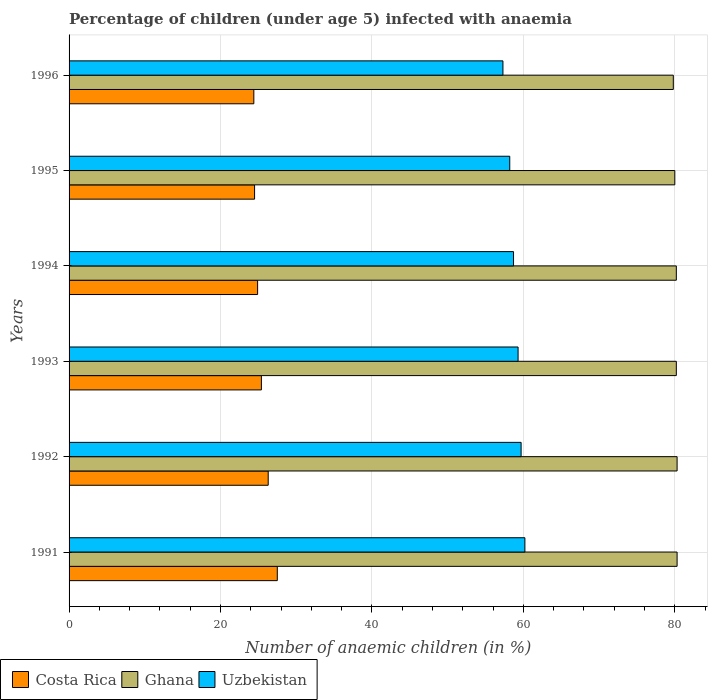How many different coloured bars are there?
Your answer should be very brief. 3. How many groups of bars are there?
Your answer should be compact. 6. How many bars are there on the 2nd tick from the top?
Your response must be concise. 3. In how many cases, is the number of bars for a given year not equal to the number of legend labels?
Offer a terse response. 0. What is the percentage of children infected with anaemia in in Uzbekistan in 1994?
Keep it short and to the point. 58.7. Across all years, what is the maximum percentage of children infected with anaemia in in Uzbekistan?
Your answer should be compact. 60.2. Across all years, what is the minimum percentage of children infected with anaemia in in Uzbekistan?
Your answer should be compact. 57.3. In which year was the percentage of children infected with anaemia in in Ghana maximum?
Your response must be concise. 1991. What is the total percentage of children infected with anaemia in in Costa Rica in the graph?
Your answer should be very brief. 153. What is the difference between the percentage of children infected with anaemia in in Uzbekistan in 1991 and that in 1993?
Provide a succinct answer. 0.9. What is the difference between the percentage of children infected with anaemia in in Ghana in 1994 and the percentage of children infected with anaemia in in Costa Rica in 1995?
Make the answer very short. 55.7. What is the average percentage of children infected with anaemia in in Ghana per year?
Keep it short and to the point. 80.13. In the year 1996, what is the difference between the percentage of children infected with anaemia in in Uzbekistan and percentage of children infected with anaemia in in Ghana?
Provide a short and direct response. -22.5. What is the ratio of the percentage of children infected with anaemia in in Uzbekistan in 1993 to that in 1996?
Make the answer very short. 1.03. Is the percentage of children infected with anaemia in in Uzbekistan in 1993 less than that in 1995?
Give a very brief answer. No. What is the difference between the highest and the lowest percentage of children infected with anaemia in in Costa Rica?
Provide a short and direct response. 3.1. In how many years, is the percentage of children infected with anaemia in in Uzbekistan greater than the average percentage of children infected with anaemia in in Uzbekistan taken over all years?
Your answer should be compact. 3. Is the sum of the percentage of children infected with anaemia in in Ghana in 1993 and 1995 greater than the maximum percentage of children infected with anaemia in in Uzbekistan across all years?
Your answer should be compact. Yes. What does the 3rd bar from the bottom in 1995 represents?
Your answer should be very brief. Uzbekistan. Is it the case that in every year, the sum of the percentage of children infected with anaemia in in Ghana and percentage of children infected with anaemia in in Costa Rica is greater than the percentage of children infected with anaemia in in Uzbekistan?
Offer a terse response. Yes. How many bars are there?
Your response must be concise. 18. How many years are there in the graph?
Provide a short and direct response. 6. What is the difference between two consecutive major ticks on the X-axis?
Your answer should be compact. 20. Are the values on the major ticks of X-axis written in scientific E-notation?
Provide a succinct answer. No. Where does the legend appear in the graph?
Keep it short and to the point. Bottom left. How many legend labels are there?
Give a very brief answer. 3. What is the title of the graph?
Offer a very short reply. Percentage of children (under age 5) infected with anaemia. What is the label or title of the X-axis?
Make the answer very short. Number of anaemic children (in %). What is the Number of anaemic children (in %) of Ghana in 1991?
Make the answer very short. 80.3. What is the Number of anaemic children (in %) in Uzbekistan in 1991?
Your response must be concise. 60.2. What is the Number of anaemic children (in %) in Costa Rica in 1992?
Ensure brevity in your answer.  26.3. What is the Number of anaemic children (in %) in Ghana in 1992?
Make the answer very short. 80.3. What is the Number of anaemic children (in %) of Uzbekistan in 1992?
Provide a succinct answer. 59.7. What is the Number of anaemic children (in %) of Costa Rica in 1993?
Give a very brief answer. 25.4. What is the Number of anaemic children (in %) of Ghana in 1993?
Give a very brief answer. 80.2. What is the Number of anaemic children (in %) in Uzbekistan in 1993?
Provide a succinct answer. 59.3. What is the Number of anaemic children (in %) of Costa Rica in 1994?
Offer a terse response. 24.9. What is the Number of anaemic children (in %) of Ghana in 1994?
Your answer should be compact. 80.2. What is the Number of anaemic children (in %) of Uzbekistan in 1994?
Offer a very short reply. 58.7. What is the Number of anaemic children (in %) of Ghana in 1995?
Your answer should be very brief. 80. What is the Number of anaemic children (in %) of Uzbekistan in 1995?
Provide a short and direct response. 58.2. What is the Number of anaemic children (in %) in Costa Rica in 1996?
Provide a short and direct response. 24.4. What is the Number of anaemic children (in %) of Ghana in 1996?
Make the answer very short. 79.8. What is the Number of anaemic children (in %) of Uzbekistan in 1996?
Your answer should be very brief. 57.3. Across all years, what is the maximum Number of anaemic children (in %) in Ghana?
Your response must be concise. 80.3. Across all years, what is the maximum Number of anaemic children (in %) of Uzbekistan?
Offer a very short reply. 60.2. Across all years, what is the minimum Number of anaemic children (in %) in Costa Rica?
Provide a succinct answer. 24.4. Across all years, what is the minimum Number of anaemic children (in %) of Ghana?
Offer a very short reply. 79.8. Across all years, what is the minimum Number of anaemic children (in %) in Uzbekistan?
Ensure brevity in your answer.  57.3. What is the total Number of anaemic children (in %) in Costa Rica in the graph?
Your answer should be very brief. 153. What is the total Number of anaemic children (in %) in Ghana in the graph?
Your answer should be compact. 480.8. What is the total Number of anaemic children (in %) of Uzbekistan in the graph?
Your answer should be compact. 353.4. What is the difference between the Number of anaemic children (in %) of Costa Rica in 1991 and that in 1992?
Offer a very short reply. 1.2. What is the difference between the Number of anaemic children (in %) of Costa Rica in 1991 and that in 1993?
Your answer should be compact. 2.1. What is the difference between the Number of anaemic children (in %) of Ghana in 1991 and that in 1993?
Provide a succinct answer. 0.1. What is the difference between the Number of anaemic children (in %) in Uzbekistan in 1991 and that in 1993?
Offer a terse response. 0.9. What is the difference between the Number of anaemic children (in %) of Costa Rica in 1991 and that in 1994?
Your answer should be very brief. 2.6. What is the difference between the Number of anaemic children (in %) in Costa Rica in 1991 and that in 1995?
Your answer should be compact. 3. What is the difference between the Number of anaemic children (in %) of Ghana in 1991 and that in 1996?
Offer a terse response. 0.5. What is the difference between the Number of anaemic children (in %) in Uzbekistan in 1991 and that in 1996?
Provide a short and direct response. 2.9. What is the difference between the Number of anaemic children (in %) in Costa Rica in 1992 and that in 1993?
Make the answer very short. 0.9. What is the difference between the Number of anaemic children (in %) in Ghana in 1992 and that in 1993?
Your answer should be compact. 0.1. What is the difference between the Number of anaemic children (in %) in Ghana in 1992 and that in 1994?
Make the answer very short. 0.1. What is the difference between the Number of anaemic children (in %) in Uzbekistan in 1992 and that in 1994?
Your response must be concise. 1. What is the difference between the Number of anaemic children (in %) in Costa Rica in 1992 and that in 1995?
Offer a very short reply. 1.8. What is the difference between the Number of anaemic children (in %) of Ghana in 1992 and that in 1996?
Ensure brevity in your answer.  0.5. What is the difference between the Number of anaemic children (in %) of Uzbekistan in 1992 and that in 1996?
Give a very brief answer. 2.4. What is the difference between the Number of anaemic children (in %) of Costa Rica in 1993 and that in 1994?
Keep it short and to the point. 0.5. What is the difference between the Number of anaemic children (in %) of Ghana in 1993 and that in 1995?
Your answer should be very brief. 0.2. What is the difference between the Number of anaemic children (in %) in Uzbekistan in 1993 and that in 1995?
Provide a succinct answer. 1.1. What is the difference between the Number of anaemic children (in %) in Costa Rica in 1993 and that in 1996?
Make the answer very short. 1. What is the difference between the Number of anaemic children (in %) in Uzbekistan in 1994 and that in 1995?
Your response must be concise. 0.5. What is the difference between the Number of anaemic children (in %) of Costa Rica in 1994 and that in 1996?
Your answer should be very brief. 0.5. What is the difference between the Number of anaemic children (in %) of Costa Rica in 1995 and that in 1996?
Your answer should be compact. 0.1. What is the difference between the Number of anaemic children (in %) in Ghana in 1995 and that in 1996?
Give a very brief answer. 0.2. What is the difference between the Number of anaemic children (in %) in Costa Rica in 1991 and the Number of anaemic children (in %) in Ghana in 1992?
Offer a terse response. -52.8. What is the difference between the Number of anaemic children (in %) in Costa Rica in 1991 and the Number of anaemic children (in %) in Uzbekistan in 1992?
Provide a short and direct response. -32.2. What is the difference between the Number of anaemic children (in %) of Ghana in 1991 and the Number of anaemic children (in %) of Uzbekistan in 1992?
Provide a short and direct response. 20.6. What is the difference between the Number of anaemic children (in %) in Costa Rica in 1991 and the Number of anaemic children (in %) in Ghana in 1993?
Keep it short and to the point. -52.7. What is the difference between the Number of anaemic children (in %) in Costa Rica in 1991 and the Number of anaemic children (in %) in Uzbekistan in 1993?
Provide a short and direct response. -31.8. What is the difference between the Number of anaemic children (in %) in Ghana in 1991 and the Number of anaemic children (in %) in Uzbekistan in 1993?
Keep it short and to the point. 21. What is the difference between the Number of anaemic children (in %) of Costa Rica in 1991 and the Number of anaemic children (in %) of Ghana in 1994?
Offer a terse response. -52.7. What is the difference between the Number of anaemic children (in %) of Costa Rica in 1991 and the Number of anaemic children (in %) of Uzbekistan in 1994?
Make the answer very short. -31.2. What is the difference between the Number of anaemic children (in %) of Ghana in 1991 and the Number of anaemic children (in %) of Uzbekistan in 1994?
Ensure brevity in your answer.  21.6. What is the difference between the Number of anaemic children (in %) in Costa Rica in 1991 and the Number of anaemic children (in %) in Ghana in 1995?
Offer a terse response. -52.5. What is the difference between the Number of anaemic children (in %) of Costa Rica in 1991 and the Number of anaemic children (in %) of Uzbekistan in 1995?
Ensure brevity in your answer.  -30.7. What is the difference between the Number of anaemic children (in %) in Ghana in 1991 and the Number of anaemic children (in %) in Uzbekistan in 1995?
Keep it short and to the point. 22.1. What is the difference between the Number of anaemic children (in %) of Costa Rica in 1991 and the Number of anaemic children (in %) of Ghana in 1996?
Your answer should be compact. -52.3. What is the difference between the Number of anaemic children (in %) of Costa Rica in 1991 and the Number of anaemic children (in %) of Uzbekistan in 1996?
Offer a very short reply. -29.8. What is the difference between the Number of anaemic children (in %) of Costa Rica in 1992 and the Number of anaemic children (in %) of Ghana in 1993?
Offer a terse response. -53.9. What is the difference between the Number of anaemic children (in %) in Costa Rica in 1992 and the Number of anaemic children (in %) in Uzbekistan in 1993?
Your response must be concise. -33. What is the difference between the Number of anaemic children (in %) of Costa Rica in 1992 and the Number of anaemic children (in %) of Ghana in 1994?
Offer a very short reply. -53.9. What is the difference between the Number of anaemic children (in %) of Costa Rica in 1992 and the Number of anaemic children (in %) of Uzbekistan in 1994?
Your response must be concise. -32.4. What is the difference between the Number of anaemic children (in %) of Ghana in 1992 and the Number of anaemic children (in %) of Uzbekistan in 1994?
Give a very brief answer. 21.6. What is the difference between the Number of anaemic children (in %) of Costa Rica in 1992 and the Number of anaemic children (in %) of Ghana in 1995?
Your response must be concise. -53.7. What is the difference between the Number of anaemic children (in %) of Costa Rica in 1992 and the Number of anaemic children (in %) of Uzbekistan in 1995?
Your answer should be compact. -31.9. What is the difference between the Number of anaemic children (in %) of Ghana in 1992 and the Number of anaemic children (in %) of Uzbekistan in 1995?
Provide a succinct answer. 22.1. What is the difference between the Number of anaemic children (in %) of Costa Rica in 1992 and the Number of anaemic children (in %) of Ghana in 1996?
Provide a short and direct response. -53.5. What is the difference between the Number of anaemic children (in %) of Costa Rica in 1992 and the Number of anaemic children (in %) of Uzbekistan in 1996?
Ensure brevity in your answer.  -31. What is the difference between the Number of anaemic children (in %) in Ghana in 1992 and the Number of anaemic children (in %) in Uzbekistan in 1996?
Your answer should be very brief. 23. What is the difference between the Number of anaemic children (in %) of Costa Rica in 1993 and the Number of anaemic children (in %) of Ghana in 1994?
Offer a very short reply. -54.8. What is the difference between the Number of anaemic children (in %) in Costa Rica in 1993 and the Number of anaemic children (in %) in Uzbekistan in 1994?
Give a very brief answer. -33.3. What is the difference between the Number of anaemic children (in %) of Costa Rica in 1993 and the Number of anaemic children (in %) of Ghana in 1995?
Provide a succinct answer. -54.6. What is the difference between the Number of anaemic children (in %) in Costa Rica in 1993 and the Number of anaemic children (in %) in Uzbekistan in 1995?
Your answer should be very brief. -32.8. What is the difference between the Number of anaemic children (in %) in Costa Rica in 1993 and the Number of anaemic children (in %) in Ghana in 1996?
Keep it short and to the point. -54.4. What is the difference between the Number of anaemic children (in %) of Costa Rica in 1993 and the Number of anaemic children (in %) of Uzbekistan in 1996?
Make the answer very short. -31.9. What is the difference between the Number of anaemic children (in %) of Ghana in 1993 and the Number of anaemic children (in %) of Uzbekistan in 1996?
Give a very brief answer. 22.9. What is the difference between the Number of anaemic children (in %) in Costa Rica in 1994 and the Number of anaemic children (in %) in Ghana in 1995?
Offer a very short reply. -55.1. What is the difference between the Number of anaemic children (in %) in Costa Rica in 1994 and the Number of anaemic children (in %) in Uzbekistan in 1995?
Make the answer very short. -33.3. What is the difference between the Number of anaemic children (in %) of Costa Rica in 1994 and the Number of anaemic children (in %) of Ghana in 1996?
Make the answer very short. -54.9. What is the difference between the Number of anaemic children (in %) in Costa Rica in 1994 and the Number of anaemic children (in %) in Uzbekistan in 1996?
Give a very brief answer. -32.4. What is the difference between the Number of anaemic children (in %) of Ghana in 1994 and the Number of anaemic children (in %) of Uzbekistan in 1996?
Your answer should be compact. 22.9. What is the difference between the Number of anaemic children (in %) of Costa Rica in 1995 and the Number of anaemic children (in %) of Ghana in 1996?
Offer a terse response. -55.3. What is the difference between the Number of anaemic children (in %) in Costa Rica in 1995 and the Number of anaemic children (in %) in Uzbekistan in 1996?
Give a very brief answer. -32.8. What is the difference between the Number of anaemic children (in %) of Ghana in 1995 and the Number of anaemic children (in %) of Uzbekistan in 1996?
Keep it short and to the point. 22.7. What is the average Number of anaemic children (in %) of Costa Rica per year?
Make the answer very short. 25.5. What is the average Number of anaemic children (in %) in Ghana per year?
Offer a very short reply. 80.13. What is the average Number of anaemic children (in %) in Uzbekistan per year?
Keep it short and to the point. 58.9. In the year 1991, what is the difference between the Number of anaemic children (in %) of Costa Rica and Number of anaemic children (in %) of Ghana?
Your answer should be compact. -52.8. In the year 1991, what is the difference between the Number of anaemic children (in %) in Costa Rica and Number of anaemic children (in %) in Uzbekistan?
Offer a terse response. -32.7. In the year 1991, what is the difference between the Number of anaemic children (in %) in Ghana and Number of anaemic children (in %) in Uzbekistan?
Keep it short and to the point. 20.1. In the year 1992, what is the difference between the Number of anaemic children (in %) of Costa Rica and Number of anaemic children (in %) of Ghana?
Keep it short and to the point. -54. In the year 1992, what is the difference between the Number of anaemic children (in %) of Costa Rica and Number of anaemic children (in %) of Uzbekistan?
Give a very brief answer. -33.4. In the year 1992, what is the difference between the Number of anaemic children (in %) of Ghana and Number of anaemic children (in %) of Uzbekistan?
Offer a terse response. 20.6. In the year 1993, what is the difference between the Number of anaemic children (in %) in Costa Rica and Number of anaemic children (in %) in Ghana?
Your answer should be compact. -54.8. In the year 1993, what is the difference between the Number of anaemic children (in %) of Costa Rica and Number of anaemic children (in %) of Uzbekistan?
Provide a short and direct response. -33.9. In the year 1993, what is the difference between the Number of anaemic children (in %) of Ghana and Number of anaemic children (in %) of Uzbekistan?
Provide a succinct answer. 20.9. In the year 1994, what is the difference between the Number of anaemic children (in %) in Costa Rica and Number of anaemic children (in %) in Ghana?
Provide a short and direct response. -55.3. In the year 1994, what is the difference between the Number of anaemic children (in %) in Costa Rica and Number of anaemic children (in %) in Uzbekistan?
Provide a succinct answer. -33.8. In the year 1994, what is the difference between the Number of anaemic children (in %) of Ghana and Number of anaemic children (in %) of Uzbekistan?
Keep it short and to the point. 21.5. In the year 1995, what is the difference between the Number of anaemic children (in %) in Costa Rica and Number of anaemic children (in %) in Ghana?
Provide a short and direct response. -55.5. In the year 1995, what is the difference between the Number of anaemic children (in %) of Costa Rica and Number of anaemic children (in %) of Uzbekistan?
Give a very brief answer. -33.7. In the year 1995, what is the difference between the Number of anaemic children (in %) in Ghana and Number of anaemic children (in %) in Uzbekistan?
Ensure brevity in your answer.  21.8. In the year 1996, what is the difference between the Number of anaemic children (in %) of Costa Rica and Number of anaemic children (in %) of Ghana?
Your answer should be very brief. -55.4. In the year 1996, what is the difference between the Number of anaemic children (in %) in Costa Rica and Number of anaemic children (in %) in Uzbekistan?
Your answer should be very brief. -32.9. In the year 1996, what is the difference between the Number of anaemic children (in %) of Ghana and Number of anaemic children (in %) of Uzbekistan?
Your answer should be compact. 22.5. What is the ratio of the Number of anaemic children (in %) in Costa Rica in 1991 to that in 1992?
Offer a very short reply. 1.05. What is the ratio of the Number of anaemic children (in %) in Uzbekistan in 1991 to that in 1992?
Give a very brief answer. 1.01. What is the ratio of the Number of anaemic children (in %) of Costa Rica in 1991 to that in 1993?
Offer a very short reply. 1.08. What is the ratio of the Number of anaemic children (in %) of Uzbekistan in 1991 to that in 1993?
Give a very brief answer. 1.02. What is the ratio of the Number of anaemic children (in %) in Costa Rica in 1991 to that in 1994?
Keep it short and to the point. 1.1. What is the ratio of the Number of anaemic children (in %) of Ghana in 1991 to that in 1994?
Keep it short and to the point. 1. What is the ratio of the Number of anaemic children (in %) in Uzbekistan in 1991 to that in 1994?
Offer a very short reply. 1.03. What is the ratio of the Number of anaemic children (in %) of Costa Rica in 1991 to that in 1995?
Make the answer very short. 1.12. What is the ratio of the Number of anaemic children (in %) in Uzbekistan in 1991 to that in 1995?
Offer a very short reply. 1.03. What is the ratio of the Number of anaemic children (in %) of Costa Rica in 1991 to that in 1996?
Your answer should be very brief. 1.13. What is the ratio of the Number of anaemic children (in %) in Ghana in 1991 to that in 1996?
Keep it short and to the point. 1.01. What is the ratio of the Number of anaemic children (in %) in Uzbekistan in 1991 to that in 1996?
Give a very brief answer. 1.05. What is the ratio of the Number of anaemic children (in %) in Costa Rica in 1992 to that in 1993?
Make the answer very short. 1.04. What is the ratio of the Number of anaemic children (in %) in Uzbekistan in 1992 to that in 1993?
Offer a terse response. 1.01. What is the ratio of the Number of anaemic children (in %) in Costa Rica in 1992 to that in 1994?
Keep it short and to the point. 1.06. What is the ratio of the Number of anaemic children (in %) of Ghana in 1992 to that in 1994?
Give a very brief answer. 1. What is the ratio of the Number of anaemic children (in %) of Uzbekistan in 1992 to that in 1994?
Provide a short and direct response. 1.02. What is the ratio of the Number of anaemic children (in %) of Costa Rica in 1992 to that in 1995?
Offer a very short reply. 1.07. What is the ratio of the Number of anaemic children (in %) in Uzbekistan in 1992 to that in 1995?
Provide a succinct answer. 1.03. What is the ratio of the Number of anaemic children (in %) of Costa Rica in 1992 to that in 1996?
Provide a succinct answer. 1.08. What is the ratio of the Number of anaemic children (in %) in Uzbekistan in 1992 to that in 1996?
Make the answer very short. 1.04. What is the ratio of the Number of anaemic children (in %) of Costa Rica in 1993 to that in 1994?
Provide a short and direct response. 1.02. What is the ratio of the Number of anaemic children (in %) in Uzbekistan in 1993 to that in 1994?
Your answer should be very brief. 1.01. What is the ratio of the Number of anaemic children (in %) of Costa Rica in 1993 to that in 1995?
Give a very brief answer. 1.04. What is the ratio of the Number of anaemic children (in %) in Ghana in 1993 to that in 1995?
Offer a very short reply. 1. What is the ratio of the Number of anaemic children (in %) of Uzbekistan in 1993 to that in 1995?
Provide a succinct answer. 1.02. What is the ratio of the Number of anaemic children (in %) in Costa Rica in 1993 to that in 1996?
Offer a very short reply. 1.04. What is the ratio of the Number of anaemic children (in %) of Ghana in 1993 to that in 1996?
Give a very brief answer. 1. What is the ratio of the Number of anaemic children (in %) in Uzbekistan in 1993 to that in 1996?
Give a very brief answer. 1.03. What is the ratio of the Number of anaemic children (in %) in Costa Rica in 1994 to that in 1995?
Your response must be concise. 1.02. What is the ratio of the Number of anaemic children (in %) in Uzbekistan in 1994 to that in 1995?
Give a very brief answer. 1.01. What is the ratio of the Number of anaemic children (in %) in Costa Rica in 1994 to that in 1996?
Provide a short and direct response. 1.02. What is the ratio of the Number of anaemic children (in %) in Uzbekistan in 1994 to that in 1996?
Your answer should be compact. 1.02. What is the ratio of the Number of anaemic children (in %) in Ghana in 1995 to that in 1996?
Offer a very short reply. 1. What is the ratio of the Number of anaemic children (in %) in Uzbekistan in 1995 to that in 1996?
Your response must be concise. 1.02. What is the difference between the highest and the second highest Number of anaemic children (in %) in Costa Rica?
Your answer should be compact. 1.2. What is the difference between the highest and the lowest Number of anaemic children (in %) of Costa Rica?
Make the answer very short. 3.1. What is the difference between the highest and the lowest Number of anaemic children (in %) of Ghana?
Ensure brevity in your answer.  0.5. 